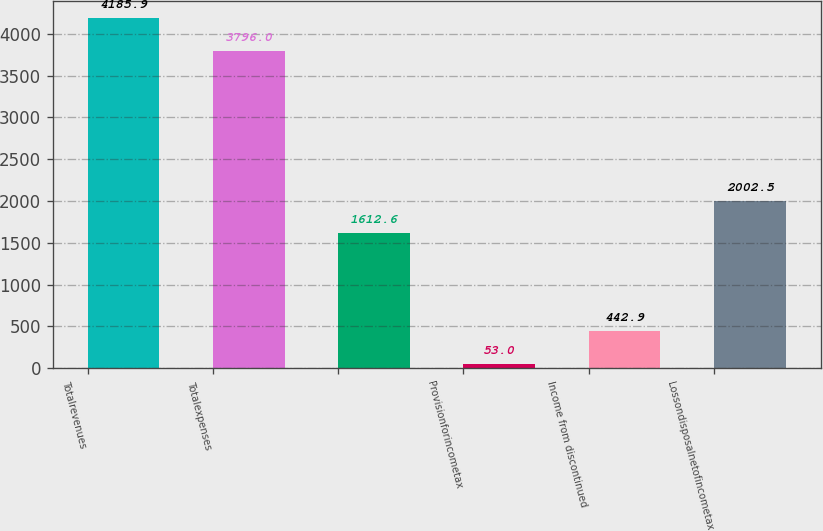<chart> <loc_0><loc_0><loc_500><loc_500><bar_chart><fcel>Totalrevenues<fcel>Totalexpenses<fcel>Unnamed: 2<fcel>Provisionforincometax<fcel>Income from discontinued<fcel>Lossondisposalnetofincometax<nl><fcel>4185.9<fcel>3796<fcel>1612.6<fcel>53<fcel>442.9<fcel>2002.5<nl></chart> 